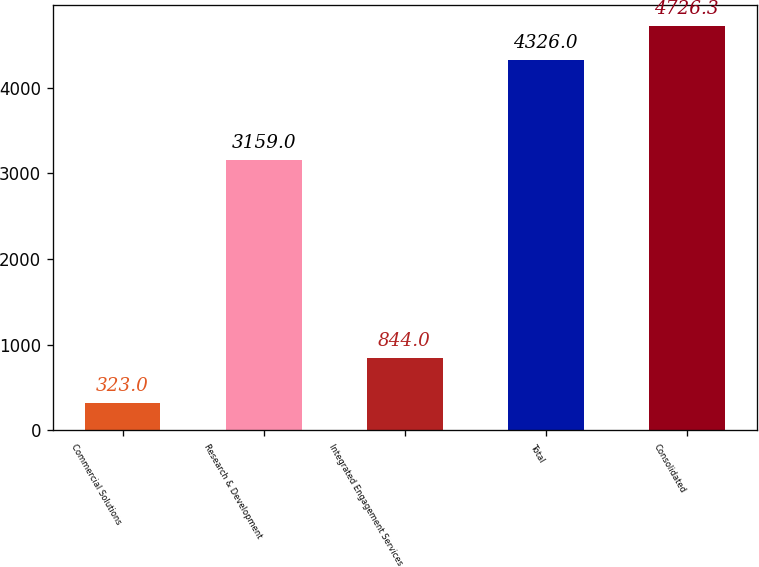Convert chart to OTSL. <chart><loc_0><loc_0><loc_500><loc_500><bar_chart><fcel>Commercial Solutions<fcel>Research & Development<fcel>Integrated Engagement Services<fcel>Total<fcel>Consolidated<nl><fcel>323<fcel>3159<fcel>844<fcel>4326<fcel>4726.3<nl></chart> 